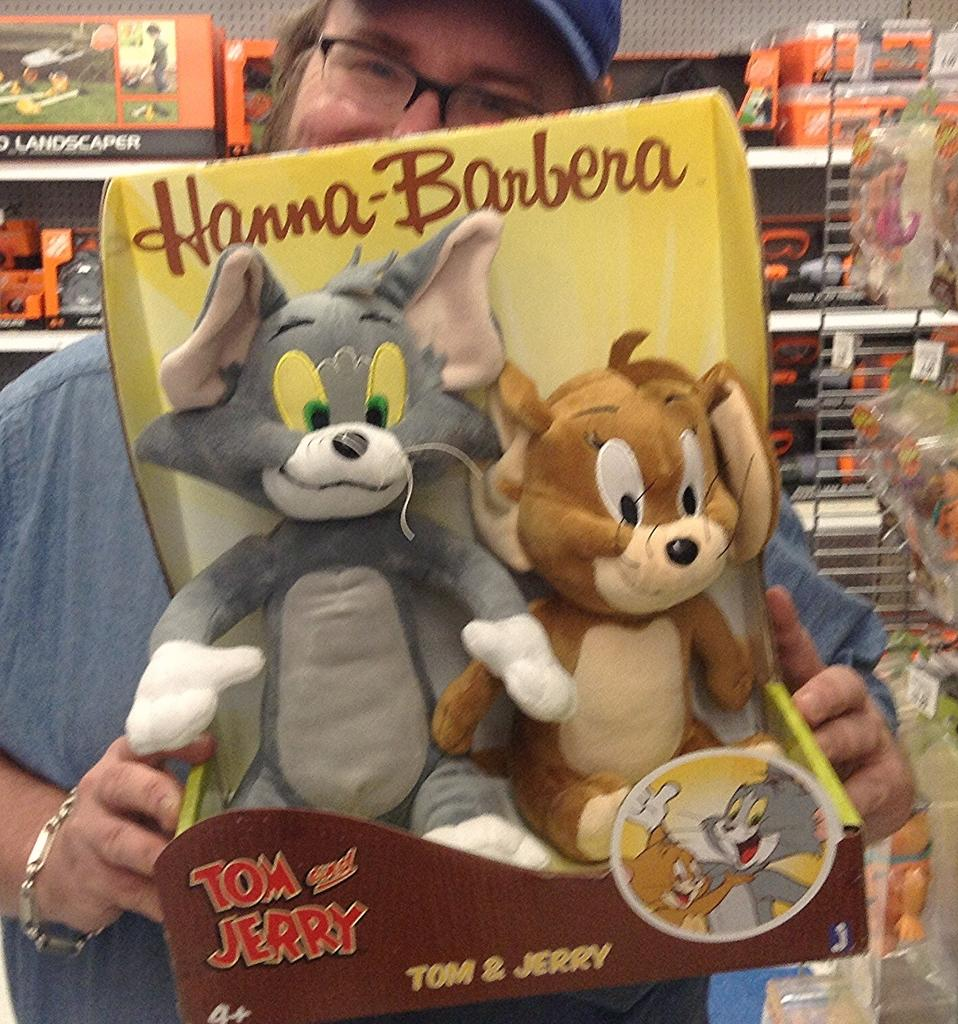Who is present in the image? There is a person in the image. What is the person holding in his hand? The person is holding toys in his hand. What can be seen in the background of the image? There are toys arranged in a rack in the background of the image. What type of badge is the person wearing in the image? There is no badge visible on the person in the image. Can you describe the spot where the person is standing in the image? The provided facts do not mention a specific spot where the person is standing, so we cannot describe it. 